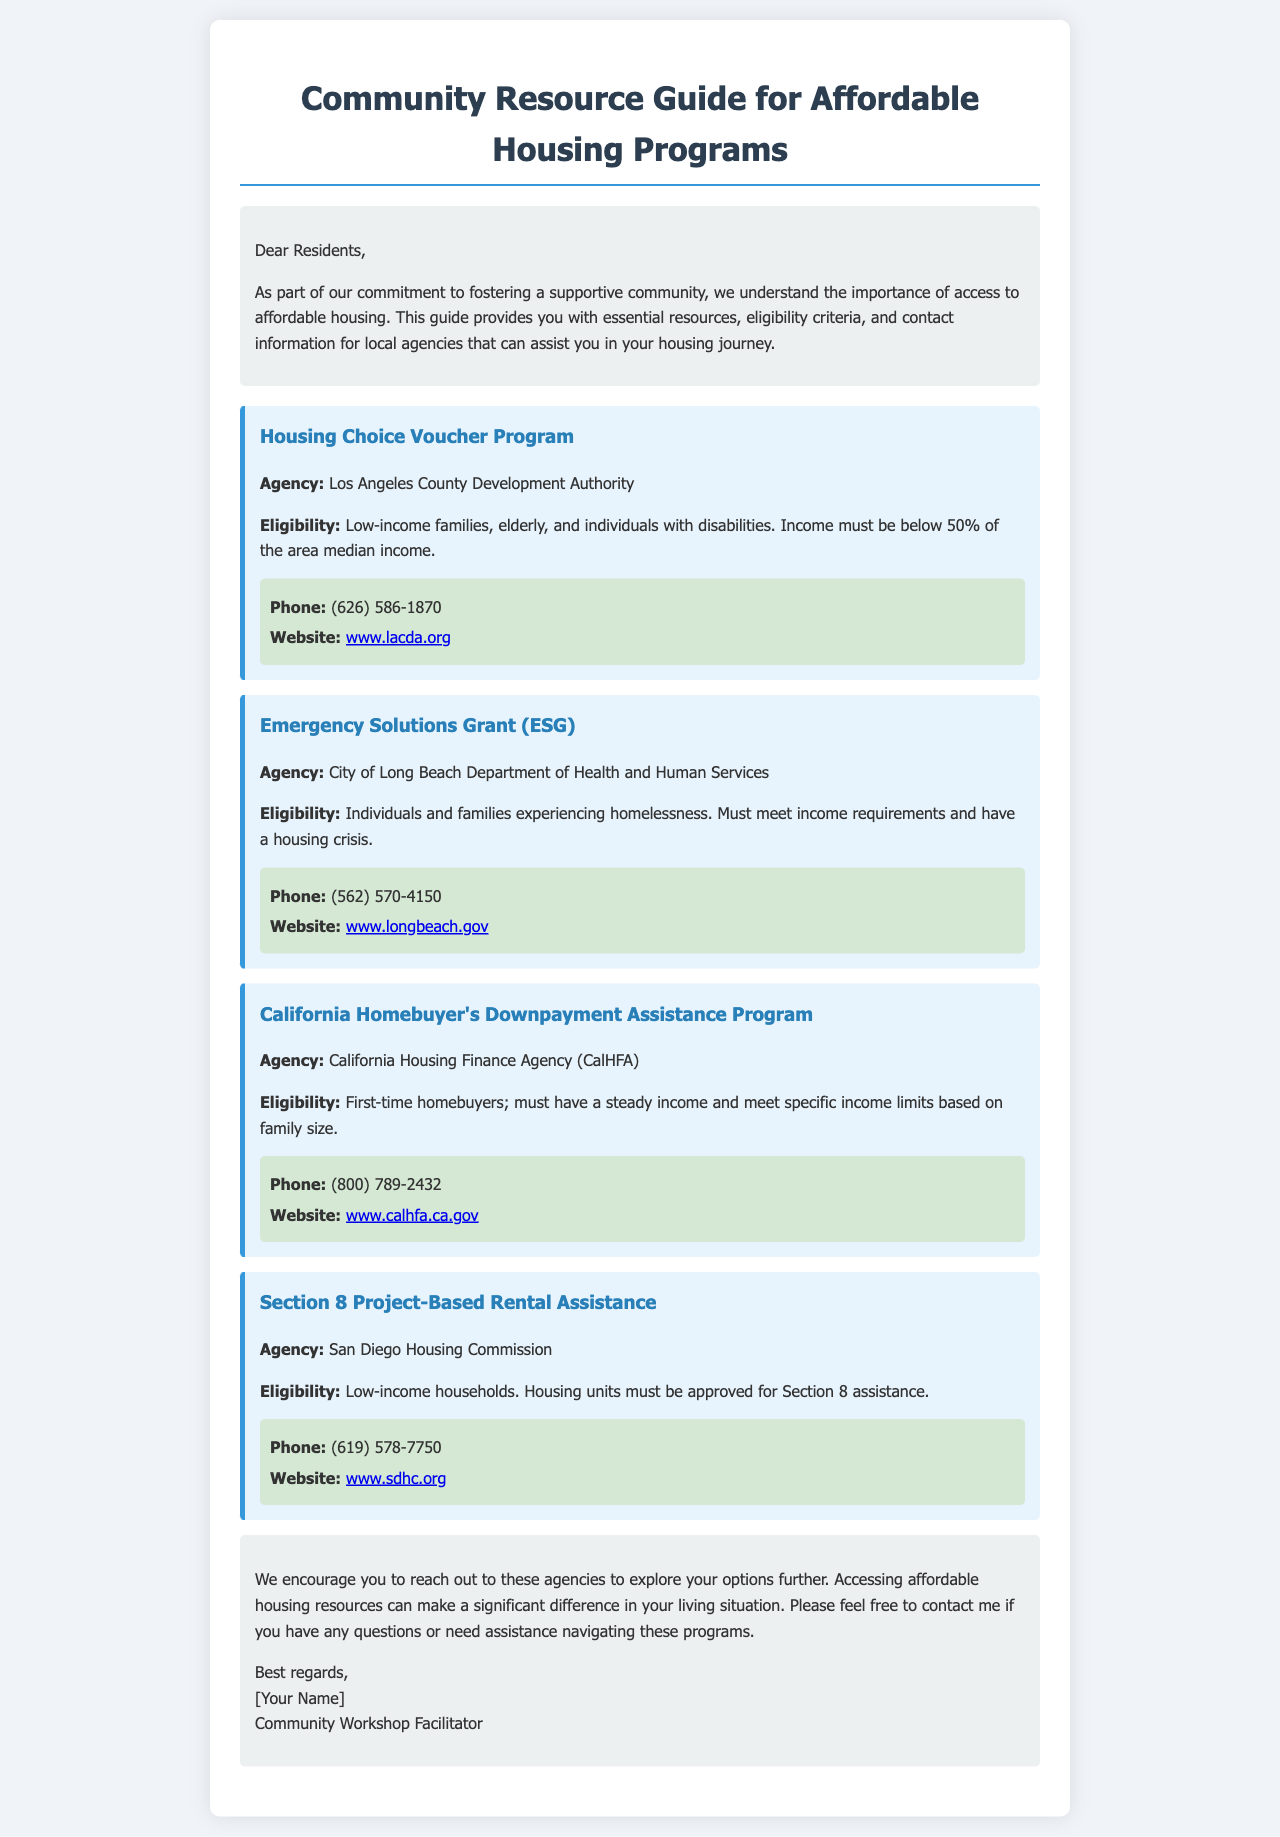What is the title of the document? The title appears prominently at the top of the document.
Answer: Community Resource Guide for Affordable Housing Programs Who administers the Housing Choice Voucher Program? The agency responsible for this program is mentioned in the first program section.
Answer: Los Angeles County Development Authority What is the income requirement for the Emergency Solutions Grant? The income requirement is specified in the eligibility section of the ESG program.
Answer: Must meet income requirements What is the phone number for the section on California Homebuyer's Downpayment Assistance Program? The phone number can be found in the contact information for that specific program.
Answer: (800) 789-2432 Which program assists individuals experiencing homelessness? This question pertains to the eligibility criteria discussed in the program descriptions.
Answer: Emergency Solutions Grant (ESG) What is the website for the San Diego Housing Commission? The website information is provided in the contact details for that program.
Answer: www.sdhc.org Which agency offers assistance for first-time homebuyers? The program related to first-time homebuyers is indicated in its title and agency section.
Answer: California Housing Finance Agency (CalHFA) What type of housing units must be approved for Section 8 assistance? This requirement is stated in the eligibility details of the Section 8 program.
Answer: Housing units What is the concluding message for residents? The conclusion section summarizes the document's intent and offers encouragement.
Answer: Accessing affordable housing resources can make a significant difference in your living situation What is the role of the author mentioned in the conclusion? The author's role is stated at the end of the document, outlining their function in the community.
Answer: Community Workshop Facilitator 